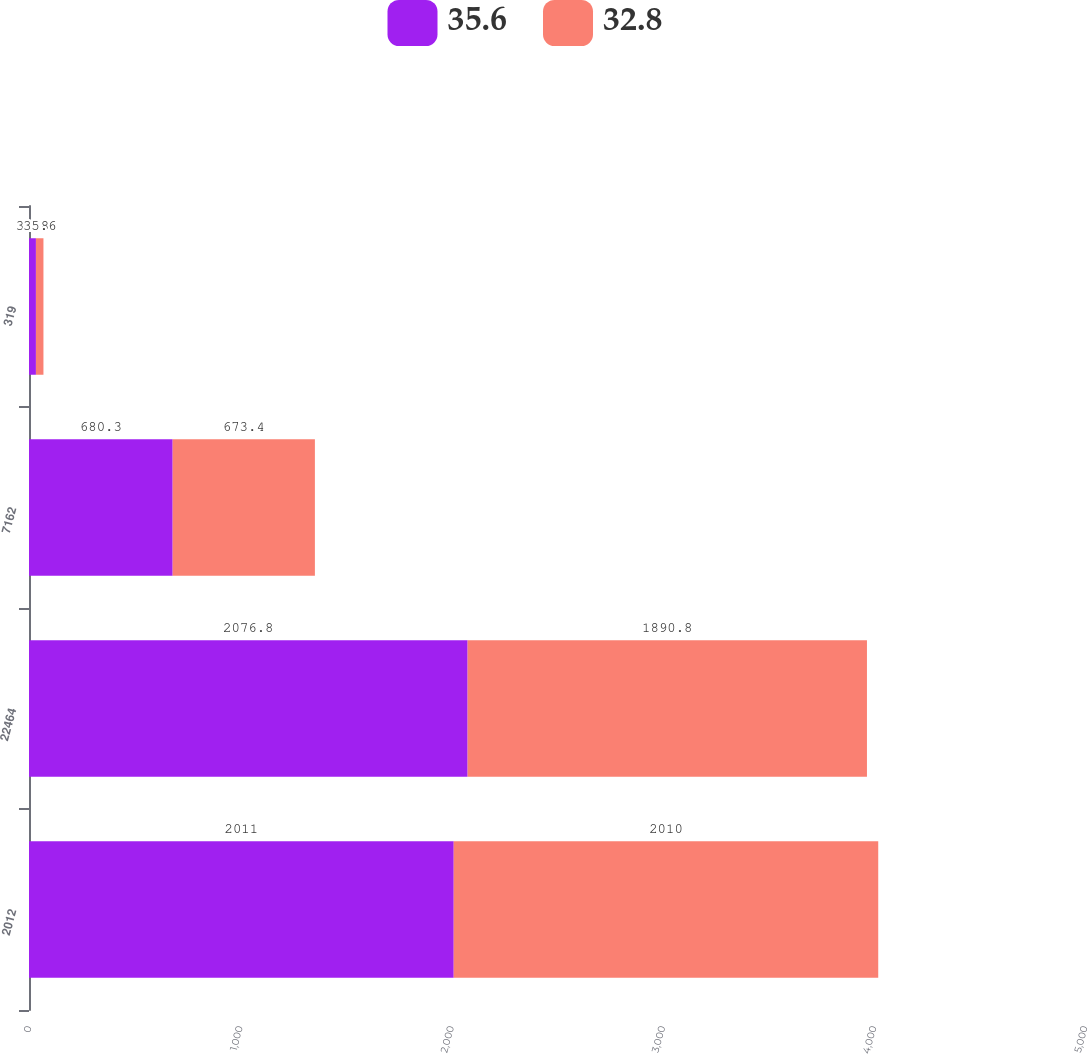<chart> <loc_0><loc_0><loc_500><loc_500><stacked_bar_chart><ecel><fcel>2012<fcel>22464<fcel>7162<fcel>319<nl><fcel>35.6<fcel>2011<fcel>2076.8<fcel>680.3<fcel>32.8<nl><fcel>32.8<fcel>2010<fcel>1890.8<fcel>673.4<fcel>35.6<nl></chart> 